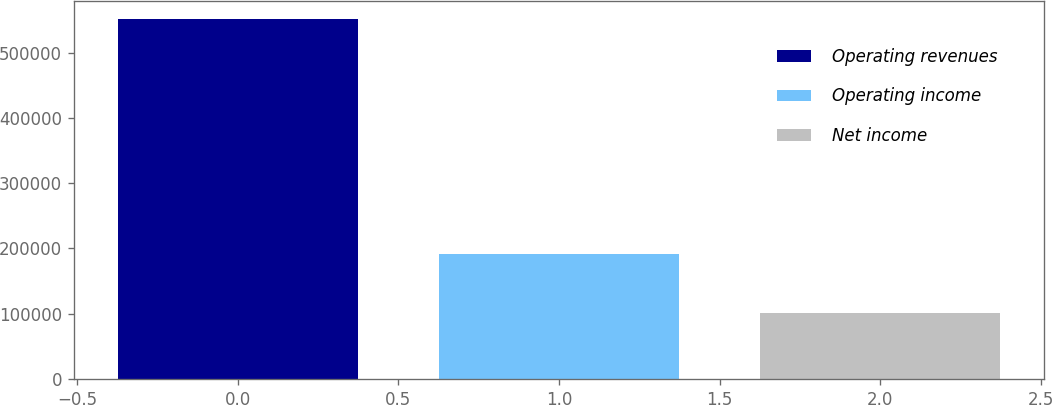Convert chart to OTSL. <chart><loc_0><loc_0><loc_500><loc_500><bar_chart><fcel>Operating revenues<fcel>Operating income<fcel>Net income<nl><fcel>551853<fcel>192173<fcel>100926<nl></chart> 